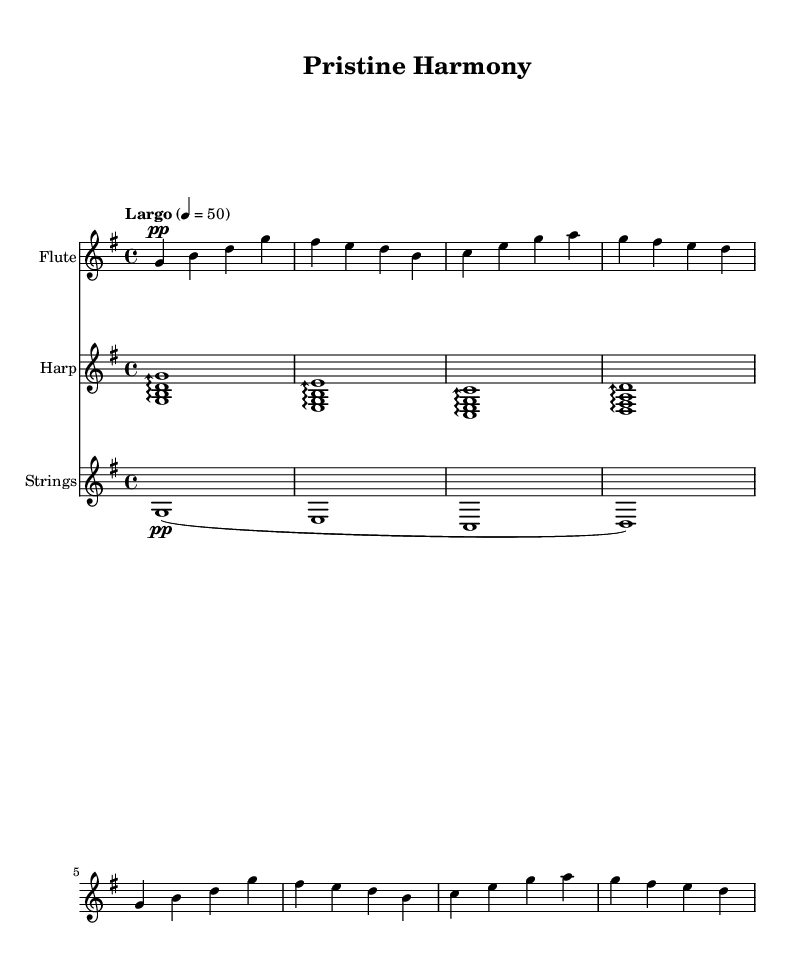What is the key signature of this music? The key signature is G major, which has one sharp (F#). This can be seen at the beginning of the staff, where the F# is indicated on the staff lines.
Answer: G major What is the time signature? The time signature is 4/4, commonly known as "four-four." It is indicated at the beginning of the music and shows that there are four beats per measure, with a quarter note getting one beat.
Answer: 4/4 What is the tempo marking? The tempo marking is "Largo," which indicates a slow pace. This term reflects the intended speed of the piece, suggesting a broad and slow performance.
Answer: Largo How many measures are in the flute part? The flute part consists of six measures, which can be counted by identifying the vertical bar lines that separate each measure in the flute staff.
Answer: 6 What dynamic is specified for the flute at the beginning? The dynamic specified for the flute at the beginning is "pp," which stands for pianissimo, meaning very soft. This indicates that the flutist should play quietly overall at the beginning of the piece.
Answer: pp Describe the texture of the music based on the instruments used. The texture of the music is characterized by a combination of flute, harp, and strings, which interact with each other, creating a light and ethereal sound, reminiscent of nature. Each instrument contributes to the overall ambient soundscape.
Answer: Ambient texture 